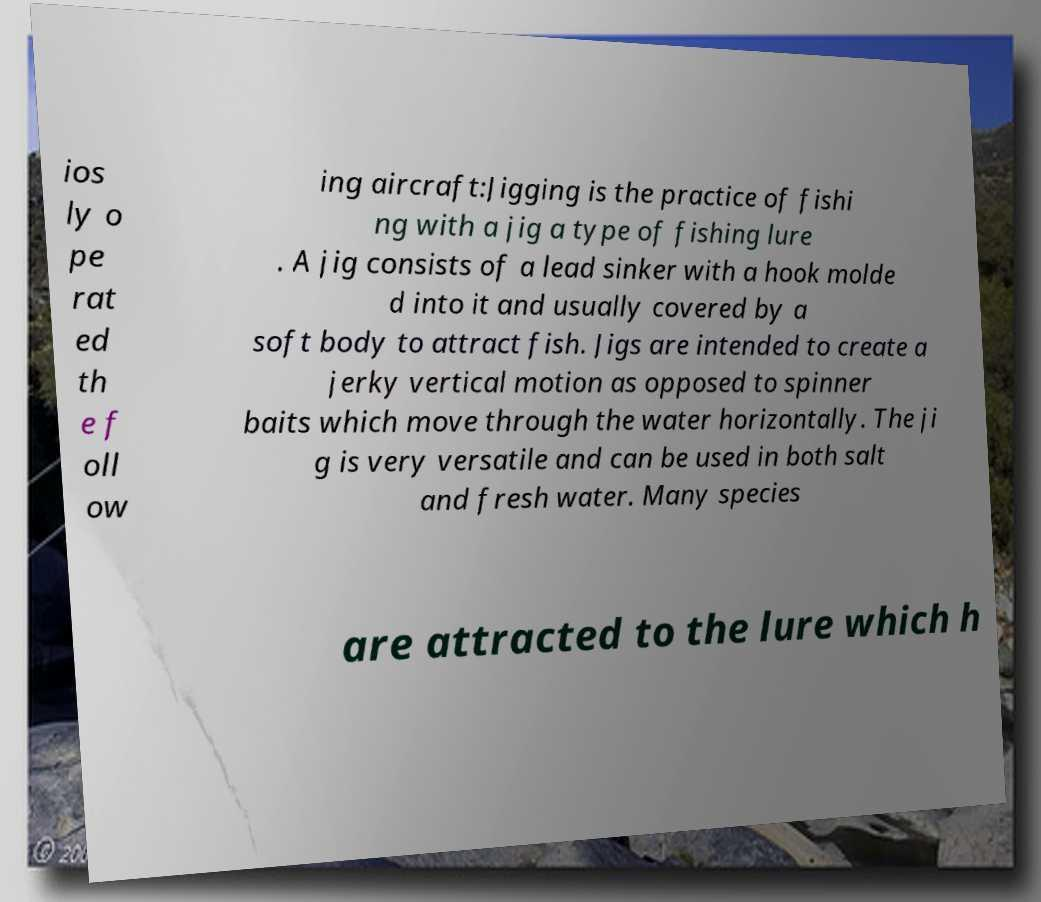Could you extract and type out the text from this image? ios ly o pe rat ed th e f oll ow ing aircraft:Jigging is the practice of fishi ng with a jig a type of fishing lure . A jig consists of a lead sinker with a hook molde d into it and usually covered by a soft body to attract fish. Jigs are intended to create a jerky vertical motion as opposed to spinner baits which move through the water horizontally. The ji g is very versatile and can be used in both salt and fresh water. Many species are attracted to the lure which h 